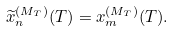Convert formula to latex. <formula><loc_0><loc_0><loc_500><loc_500>\widetilde { x } _ { n } ^ { ( M _ { T } ) } ( T ) = x _ { m } ^ { ( M _ { T } ) } ( T ) .</formula> 